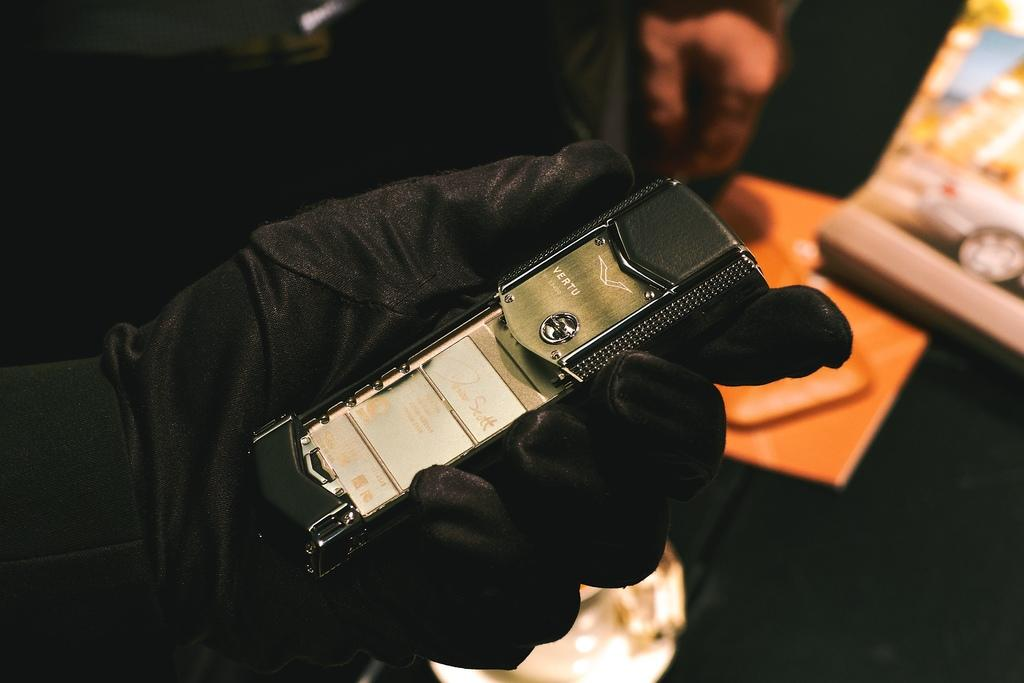What is the person holding in their hand in the image? The fact does not specify what the person is holding, so we cannot definitively answer this question. How many people are in the image? There are two people in the image. What objects are on the table in the image? There is a book and a box on the table in the image. What type of ring is the person wearing on their left hand in the image? There is no mention of a ring or any jewelry in the image, so we cannot answer this question. 